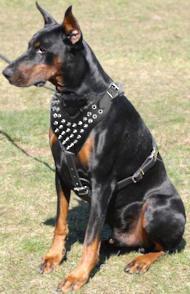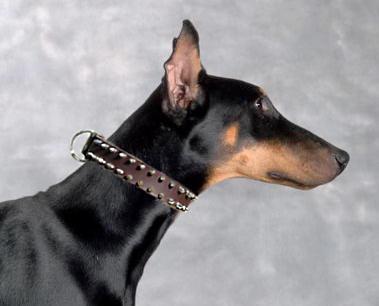The first image is the image on the left, the second image is the image on the right. For the images displayed, is the sentence "Each image shows at least one doberman wearing a collar, and one image shows a camera-gazing close-mouthed dog in a chain collar, while the other image includes a rightward-gazing dog with its pink tongue hanging out." factually correct? Answer yes or no. No. The first image is the image on the left, the second image is the image on the right. Given the left and right images, does the statement "At least one doberman has its tongue out." hold true? Answer yes or no. No. 